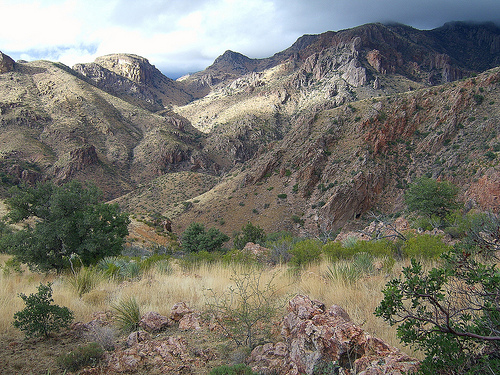<image>
Is the mountain on the rock? No. The mountain is not positioned on the rock. They may be near each other, but the mountain is not supported by or resting on top of the rock. 